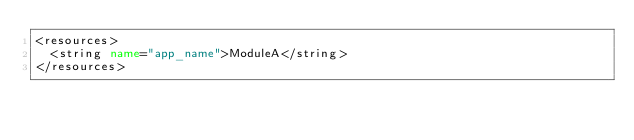Convert code to text. <code><loc_0><loc_0><loc_500><loc_500><_XML_><resources>
  <string name="app_name">ModuleA</string>
</resources>
</code> 